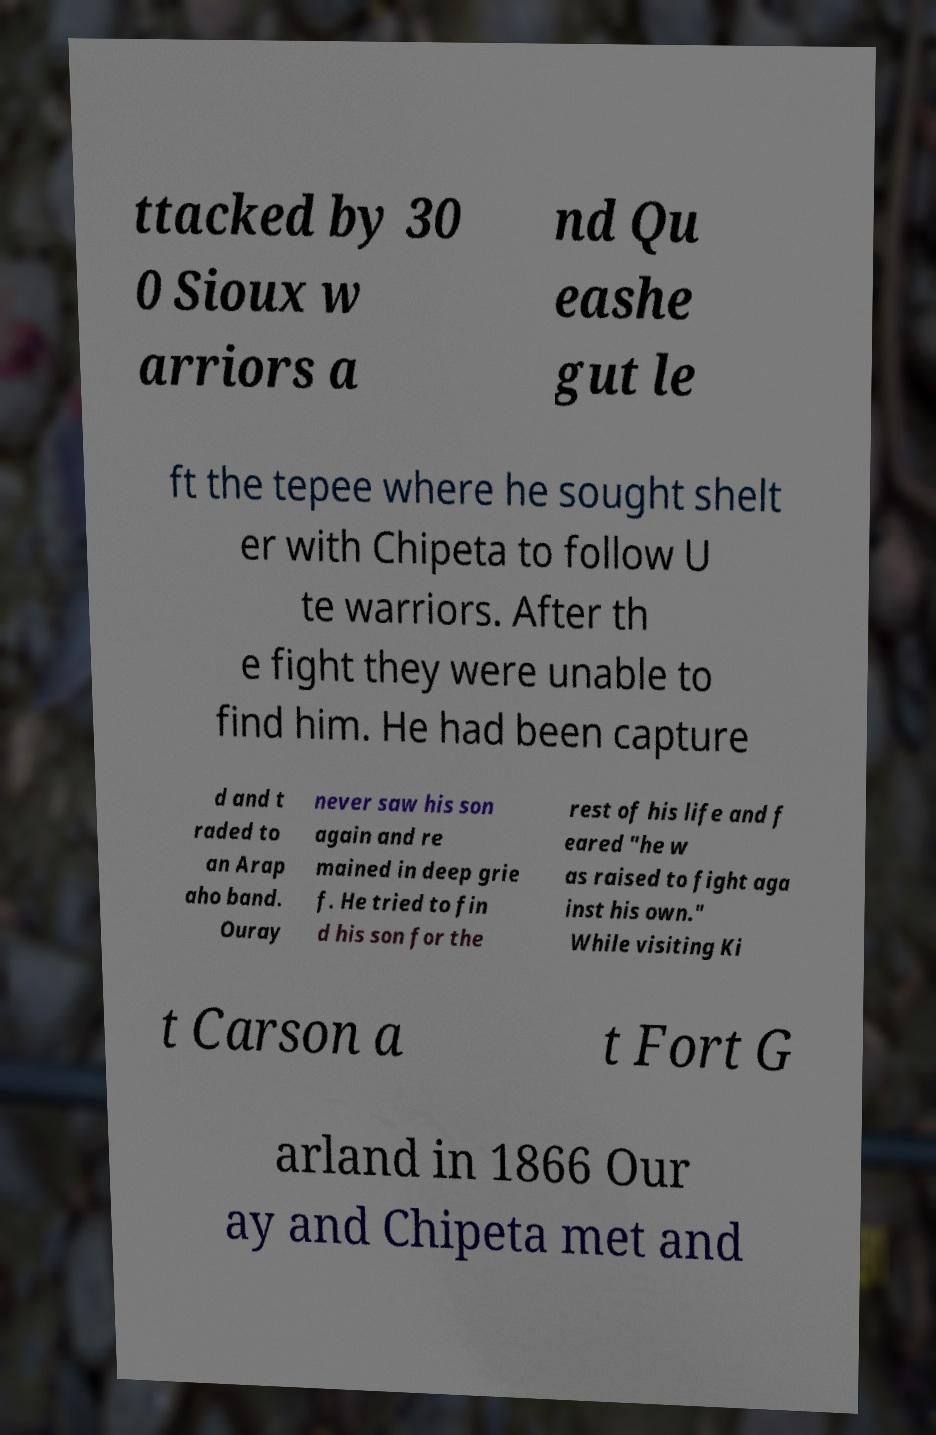Please read and relay the text visible in this image. What does it say? ttacked by 30 0 Sioux w arriors a nd Qu eashe gut le ft the tepee where he sought shelt er with Chipeta to follow U te warriors. After th e fight they were unable to find him. He had been capture d and t raded to an Arap aho band. Ouray never saw his son again and re mained in deep grie f. He tried to fin d his son for the rest of his life and f eared "he w as raised to fight aga inst his own." While visiting Ki t Carson a t Fort G arland in 1866 Our ay and Chipeta met and 